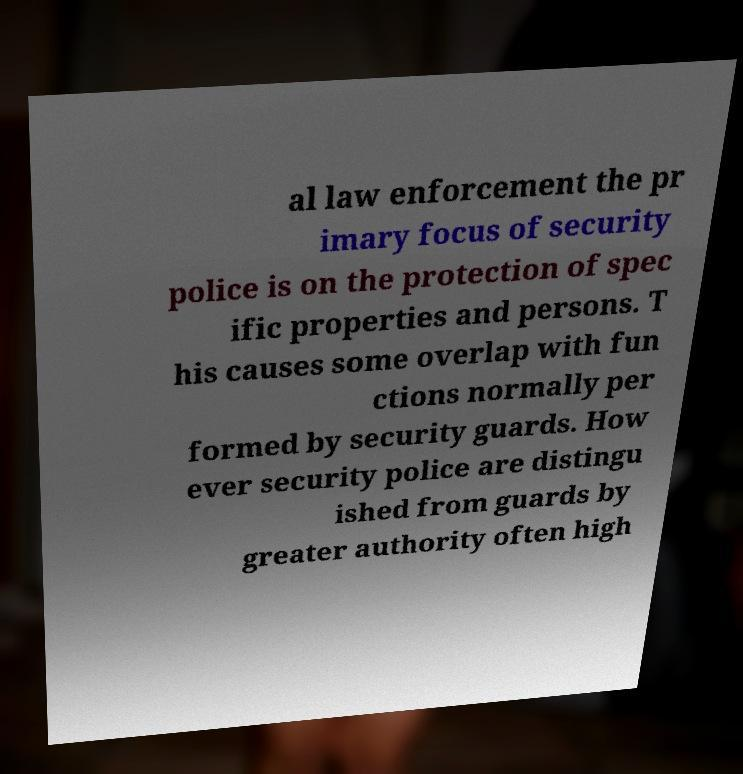Can you read and provide the text displayed in the image?This photo seems to have some interesting text. Can you extract and type it out for me? al law enforcement the pr imary focus of security police is on the protection of spec ific properties and persons. T his causes some overlap with fun ctions normally per formed by security guards. How ever security police are distingu ished from guards by greater authority often high 